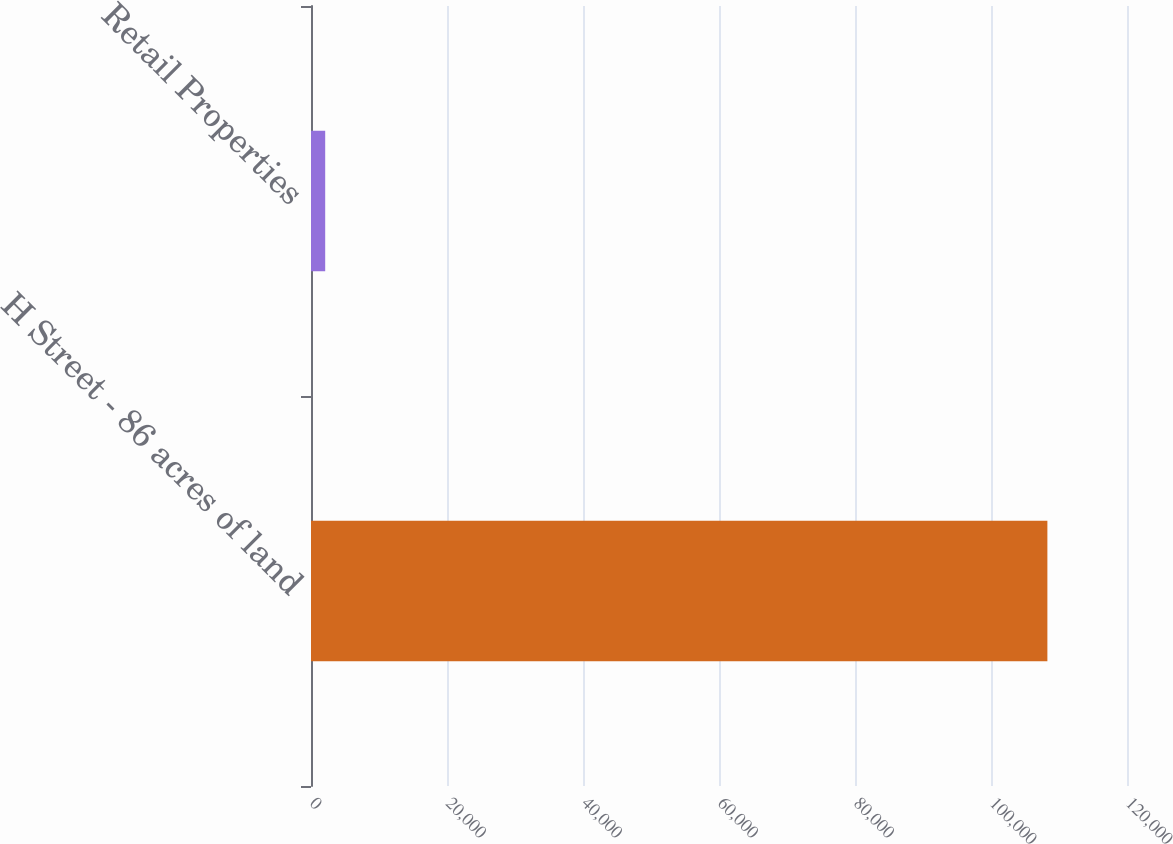<chart> <loc_0><loc_0><loc_500><loc_500><bar_chart><fcel>H Street - 86 acres of land<fcel>Retail Properties<nl><fcel>108292<fcel>2088<nl></chart> 